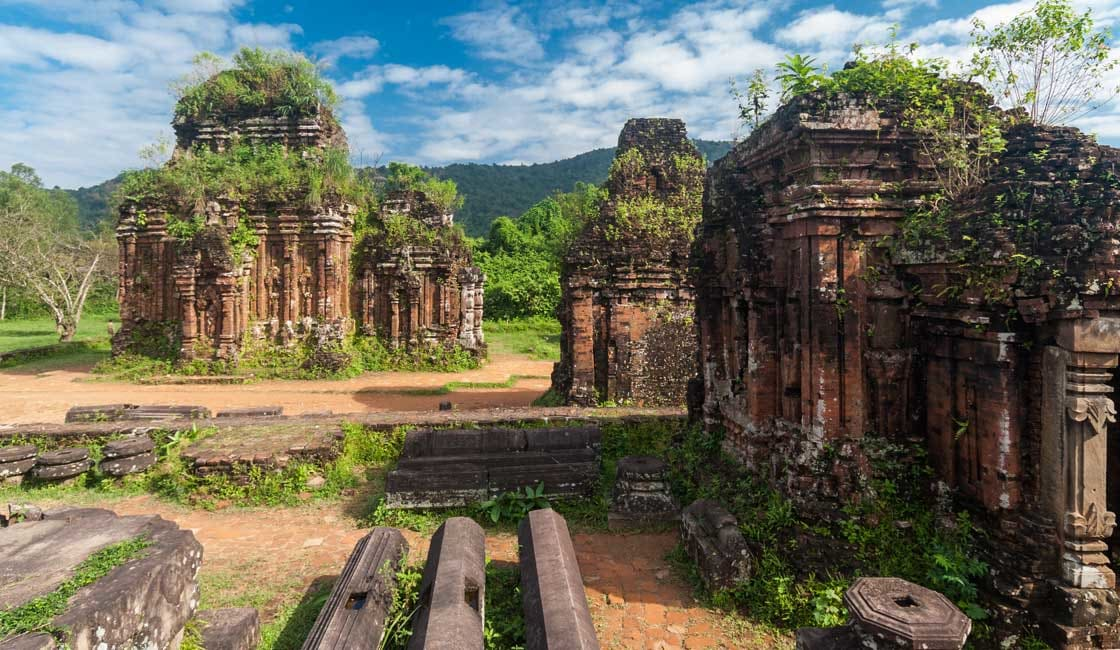What is this photo about? This photo depicts the My Son Sanctuary, a UNESCO World Heritage site in Vietnam. Dating back to the 4th to 13th centuries, these ruins of Hindu temples were constructed by the kings of Champa and dedicated to various deities including Shiva. The brick and stone structures, although in ruins, still showcase the remarkable ingenuity and creativity of Cham architecture, characterized by their detailed carvings and geometric patterns. The temples are set against a backdrop of a dramatic mountain landscape, nestled within a lush forest setting that attests to the careful balance between construction and nature revered by the Cham people. This image, capturing the interplay between the ancient works of man and the enveloping arms of nature, invites reflection on the passage of time and the resilience of human spirit and devotion. 